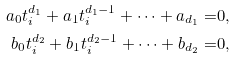<formula> <loc_0><loc_0><loc_500><loc_500>a _ { 0 } t _ { i } ^ { d _ { 1 } } + a _ { 1 } t _ { i } ^ { d _ { 1 } - 1 } + \cdots + a _ { d _ { 1 } } = & 0 , \\ b _ { 0 } t _ { i } ^ { d _ { 2 } } + b _ { 1 } t _ { i } ^ { d _ { 2 } - 1 } + \cdots + b _ { d _ { 2 } } = & 0 ,</formula> 